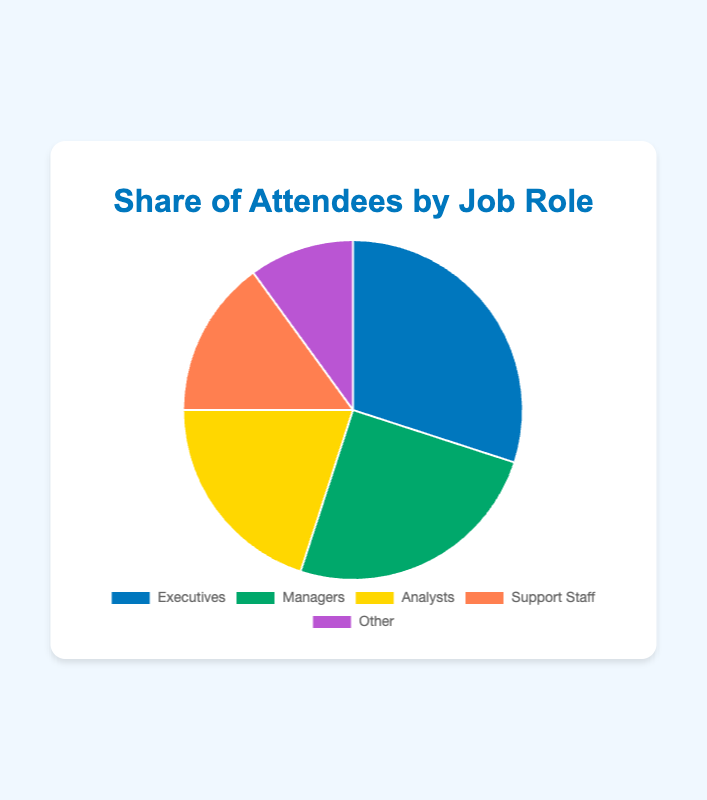What percentage of attendees are in non-managerial roles (Analysts, Support Staff, Other)? Add the percentages of Analysts (20%), Support Staff (15%), and Other (10%). So, 20% + 15% + 10% = 45%.
Answer: 45% Which job role has the smallest share of attendees? Compare the percentages of all job roles. The Other category has the lowest share at 10%.
Answer: Other How much larger is the share of Executives compared to the share of Support Staff? Subtract the percentage of Support Staff (15%) from the percentage of Executives (30%). So, 30% - 15% = 15%.
Answer: 15% What is the combined share of Managers and Analysts? Add the percentages of Managers (25%) and Analysts (20%). So, 25% + 20% = 45%.
Answer: 45% Which job role has a 20% share of attendees? Based on the figure, Analysts have a 20% share.
Answer: Analysts What is the difference in the share of attendees between Executives and Managers? Subtract the percentage of Managers (25%) from the percentage of Executives (30%). So, 30% - 25% = 5%.
Answer: 5% What color represents the Managers on the pie chart? The color used for Managers is green.
Answer: Green If you were to accumulate the shares of the two largest job roles, what would be the total percentage? Add the percentages of Executives (30%) and Managers (25%). So, 30% + 25% = 55%.
Answer: 55% Which job roles have a share greater than 15%? Compare the percentages of all job roles. Executives (30%), Managers (25%), and Analysts (20%) each have a share greater than 15%.
Answer: Executives, Managers, Analysts 